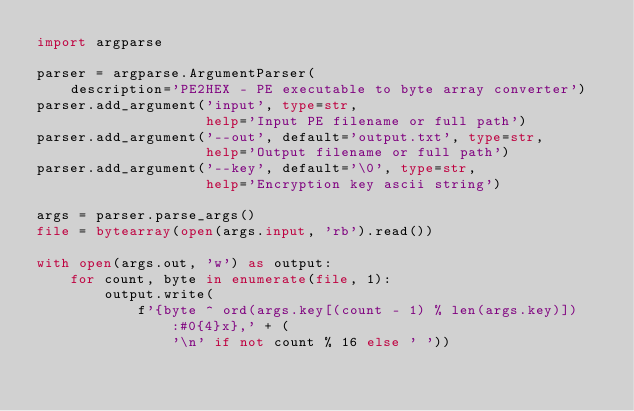Convert code to text. <code><loc_0><loc_0><loc_500><loc_500><_Python_>import argparse

parser = argparse.ArgumentParser(
    description='PE2HEX - PE executable to byte array converter')
parser.add_argument('input', type=str,
                    help='Input PE filename or full path')
parser.add_argument('--out', default='output.txt', type=str,
                    help='Output filename or full path')
parser.add_argument('--key', default='\0', type=str,
                    help='Encryption key ascii string')

args = parser.parse_args()
file = bytearray(open(args.input, 'rb').read())

with open(args.out, 'w') as output:
    for count, byte in enumerate(file, 1):
        output.write(
            f'{byte ^ ord(args.key[(count - 1) % len(args.key)]):#0{4}x},' + (
                '\n' if not count % 16 else ' '))
</code> 